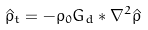<formula> <loc_0><loc_0><loc_500><loc_500>\hat { \rho } _ { t } = - \rho _ { 0 } G _ { d } * \nabla ^ { 2 } \hat { \rho }</formula> 